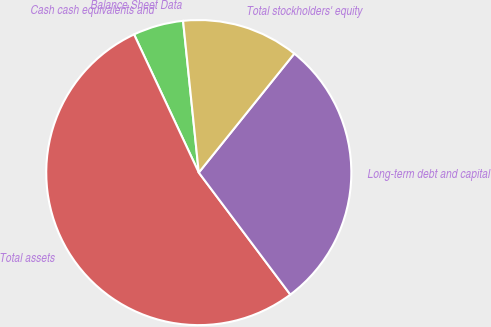<chart> <loc_0><loc_0><loc_500><loc_500><pie_chart><fcel>Balance Sheet Data<fcel>Cash cash equivalents and<fcel>Total assets<fcel>Long-term debt and capital<fcel>Total stockholders' equity<nl><fcel>0.0%<fcel>5.33%<fcel>53.27%<fcel>28.99%<fcel>12.41%<nl></chart> 